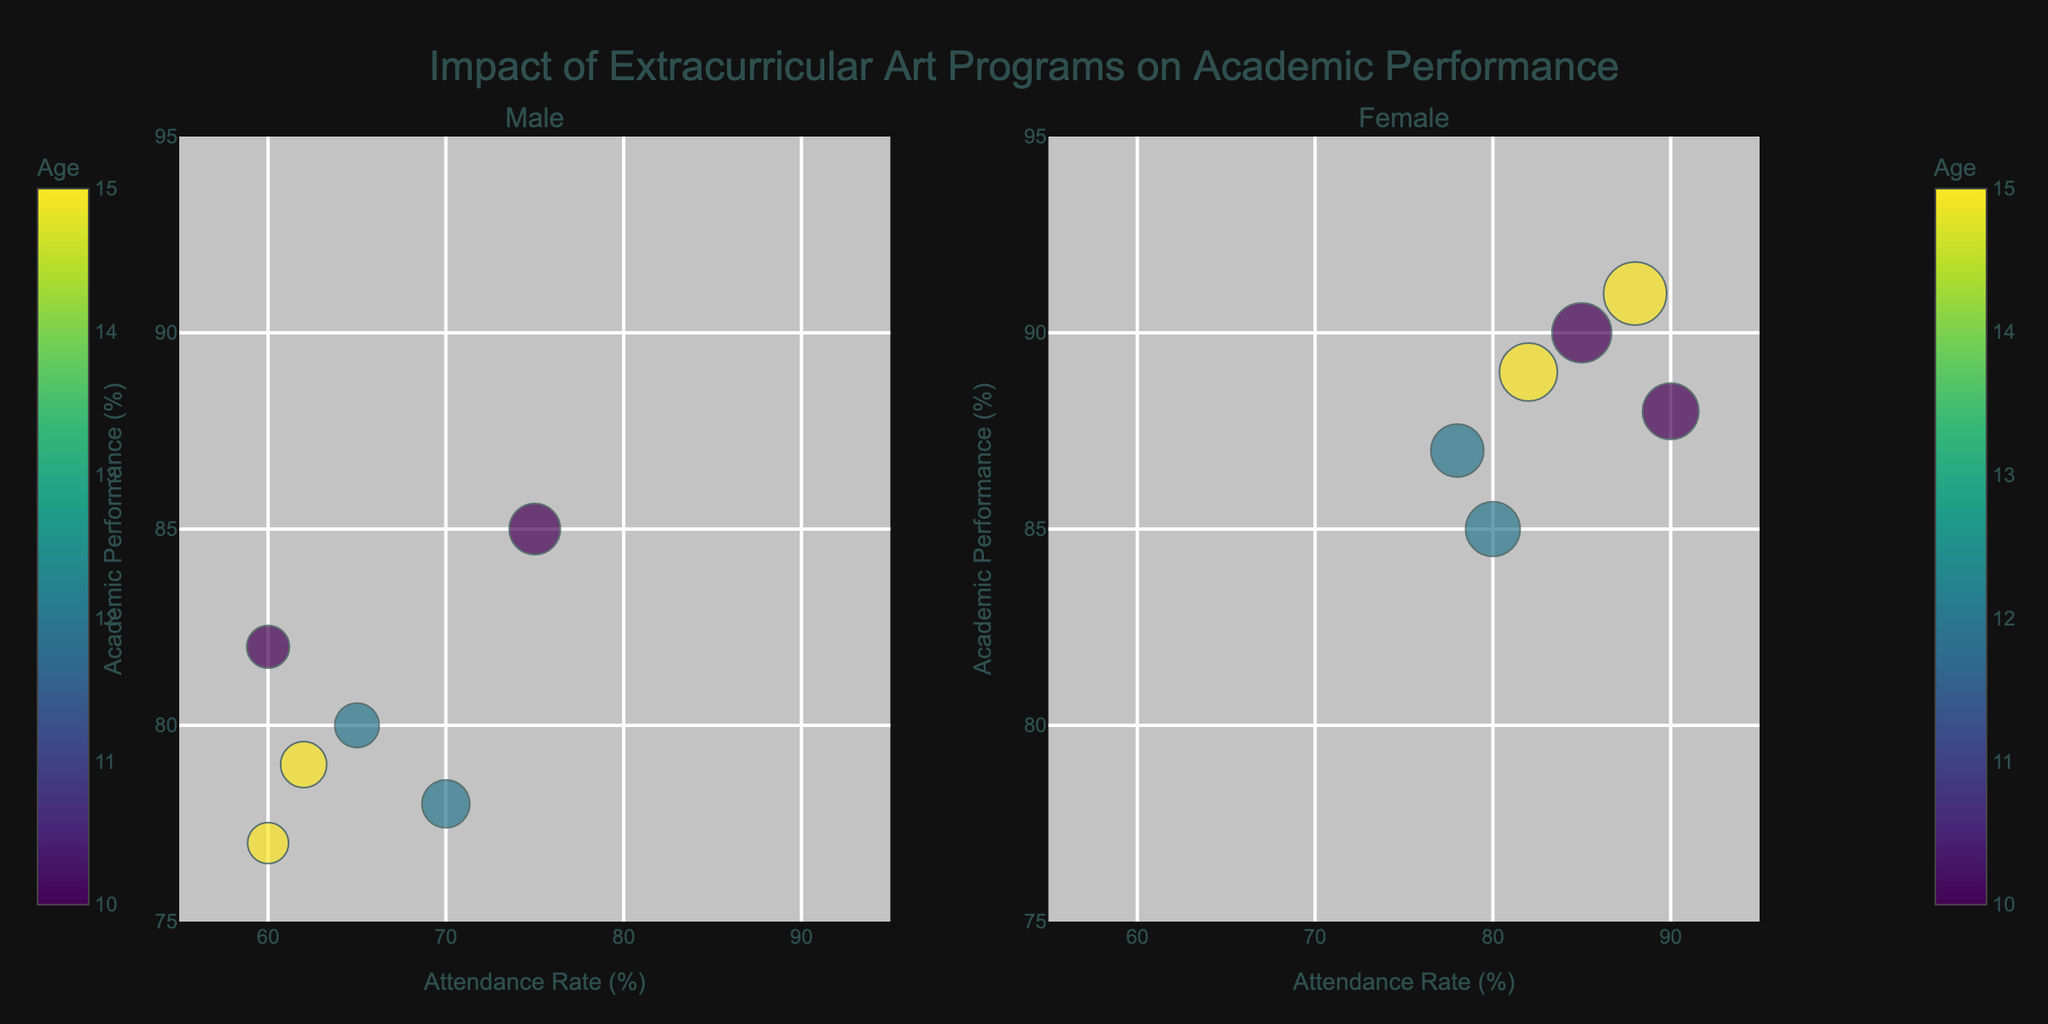What's the main title of the figure? The main title is shown at the top center of the figure. It reads 'Impact of Extracurricular Art Programs on Academic Performance'.
Answer: 'Impact of Extracurricular Art Programs on Academic Performance' How is age represented in the bubble chart? Age is represented by the color of the bubbles. The color scale used is sequential Viridis, with different colors corresponding to different ages.
Answer: By color What range can we see on the x-axis and y-axis? The x-axis represents the Attendance Rate and ranges from 55% to 95%. The y-axis represents the Academic Performance and ranges from 75% to 95%.
Answer: 55-95% for x-axis and 75-95% for y-axis Which gender has higher academic performance for the Drawing art program at age 10? Look at the subplot for 10-year-olds participating in the Drawing program. The subplot on the left shows males with an academic performance of 82%, and the subplot on the right shows females with an academic performance of 88%.
Answer: Females What is the average Attendance Rate for 15-year-old students in the Female category? To find this, sum the Attendance Rates for 15-year-old females: 88% (Dance) + 82% (Digital Art) = 170%. Then divide by the number of data points, which is 2. 170/2 = 85%.
Answer: 85% Comparing females in different age groups, which age group has the highest attendance rate? Look at the attendance rates for all females in the figure by each age group. The highest attendance rates are 90% for 10-year-olds, 80% for 12-year-olds, and 88% for 15-year-olds.
Answer: 10-year-olds Between males and females at age 12 in the Theater program, who has better academic performance and by how much? Compare the academic performances for males and females in the 12-year-old Theater program. Male performance is 78%, and female performance is 85%. The difference is 85% - 78% = 7%.
Answer: Females, by 7% On which subplot and for which gender does the Digital Art program appear, and what is the attendance rate for a 15-year-old in this program? The Digital Art program appears in both subplots, but for this query, we look in the Female subplot for 15-year-olds. The attendance rate for females in Digital Art is 82%.
Answer: Female subplot, 82% For which art program and age is the academic performance the highest, regardless of gender? Find the highest academic performance and read the associated program and age. The highest performance is 91% for the 15-year-old females in the Dance program.
Answer: Dance, 15 years old 